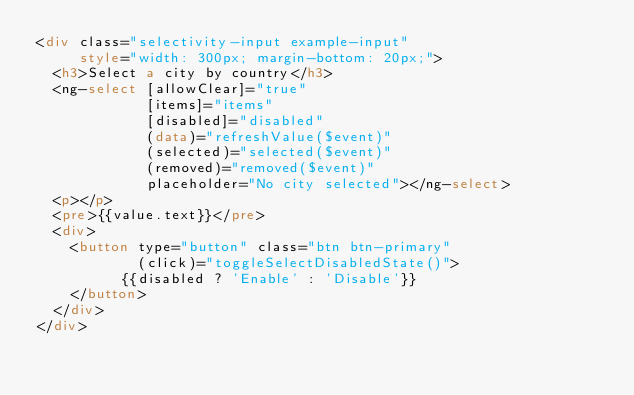Convert code to text. <code><loc_0><loc_0><loc_500><loc_500><_HTML_><div class="selectivity-input example-input"
     style="width: 300px; margin-bottom: 20px;">
  <h3>Select a city by country</h3>
  <ng-select [allowClear]="true"
             [items]="items"
             [disabled]="disabled"
             (data)="refreshValue($event)"
             (selected)="selected($event)"
             (removed)="removed($event)"
             placeholder="No city selected"></ng-select>
  <p></p>
  <pre>{{value.text}}</pre>
  <div>
    <button type="button" class="btn btn-primary"
            (click)="toggleSelectDisabledState()">
          {{disabled ? 'Enable' : 'Disable'}}
    </button>
  </div>
</div>
</code> 